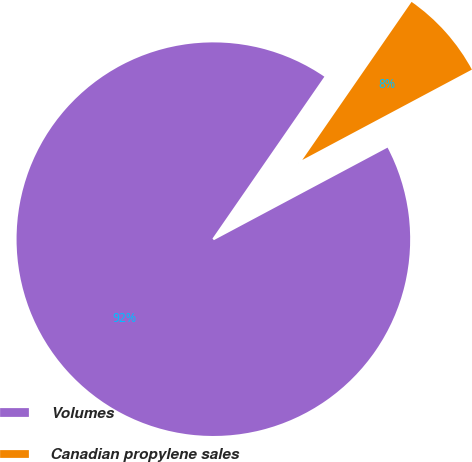Convert chart. <chart><loc_0><loc_0><loc_500><loc_500><pie_chart><fcel>Volumes<fcel>Canadian propylene sales<nl><fcel>92.42%<fcel>7.58%<nl></chart> 